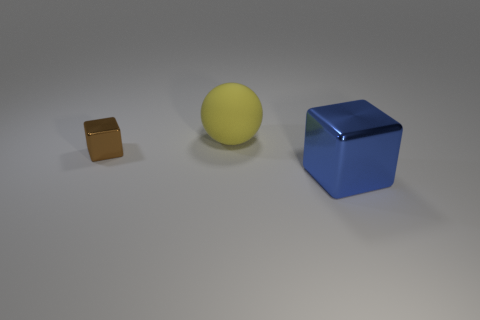Add 2 big shiny things. How many objects exist? 5 Subtract all blocks. How many objects are left? 1 Subtract 0 brown spheres. How many objects are left? 3 Subtract all brown cubes. Subtract all green cylinders. How many cubes are left? 1 Subtract all big blue cubes. Subtract all big red balls. How many objects are left? 2 Add 3 yellow things. How many yellow things are left? 4 Add 3 cubes. How many cubes exist? 5 Subtract all brown blocks. How many blocks are left? 1 